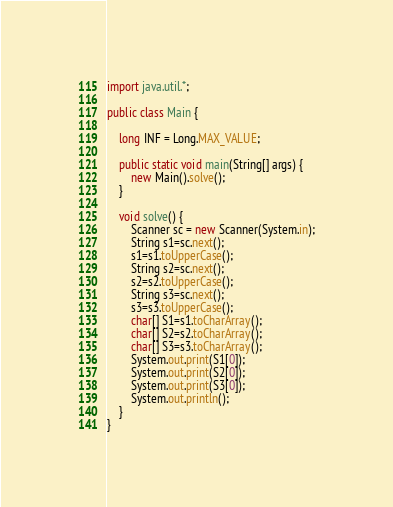Convert code to text. <code><loc_0><loc_0><loc_500><loc_500><_Java_>import java.util.*;

public class Main {

    long INF = Long.MAX_VALUE;

    public static void main(String[] args) {
        new Main().solve();
    }

    void solve() {
        Scanner sc = new Scanner(System.in);
        String s1=sc.next();
        s1=s1.toUpperCase();
        String s2=sc.next();
        s2=s2.toUpperCase();
        String s3=sc.next();
        s3=s3.toUpperCase();
        char[] S1=s1.toCharArray();
        char[] S2=s2.toCharArray();
        char[] S3=s3.toCharArray();
        System.out.print(S1[0]);
        System.out.print(S2[0]);
        System.out.print(S3[0]);
        System.out.println();
    }
}
</code> 